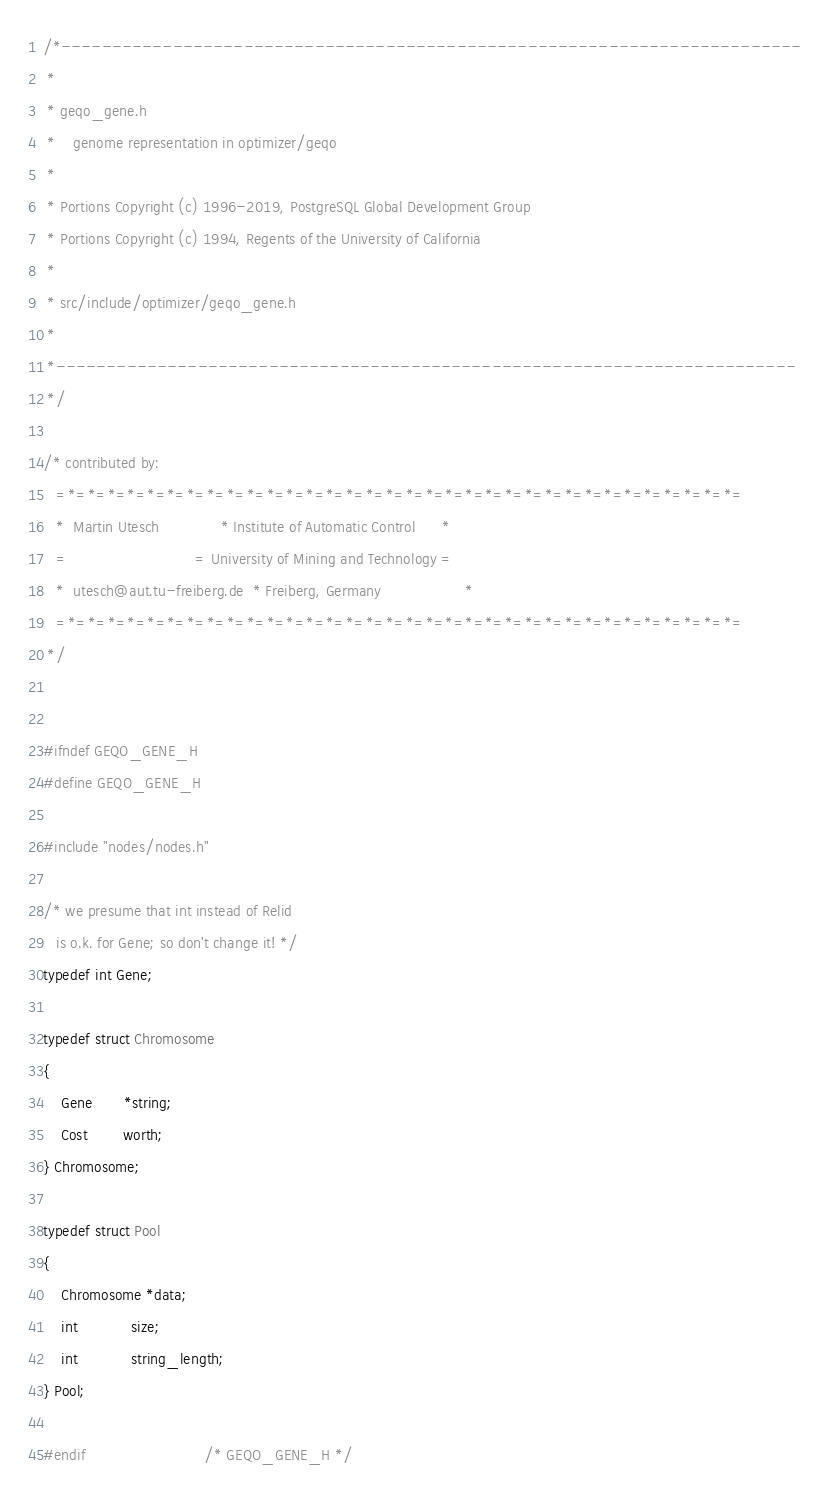Convert code to text. <code><loc_0><loc_0><loc_500><loc_500><_C_>/*-------------------------------------------------------------------------
 *
 * geqo_gene.h
 *	  genome representation in optimizer/geqo
 *
 * Portions Copyright (c) 1996-2019, PostgreSQL Global Development Group
 * Portions Copyright (c) 1994, Regents of the University of California
 *
 * src/include/optimizer/geqo_gene.h
 *
 *-------------------------------------------------------------------------
 */

/* contributed by:
   =*=*=*=*=*=*=*=*=*=*=*=*=*=*=*=*=*=*=*=*=*=*=*=*=*=*=*=*=*=*=*=*=*=*=
   *  Martin Utesch				 * Institute of Automatic Control	   *
   =							 = University of Mining and Technology =
   *  utesch@aut.tu-freiberg.de  * Freiberg, Germany				   *
   =*=*=*=*=*=*=*=*=*=*=*=*=*=*=*=*=*=*=*=*=*=*=*=*=*=*=*=*=*=*=*=*=*=*=
 */


#ifndef GEQO_GENE_H
#define GEQO_GENE_H

#include "nodes/nodes.h"

/* we presume that int instead of Relid
   is o.k. for Gene; so don't change it! */
typedef int Gene;

typedef struct Chromosome
{
	Gene	   *string;
	Cost		worth;
} Chromosome;

typedef struct Pool
{
	Chromosome *data;
	int			size;
	int			string_length;
} Pool;

#endif							/* GEQO_GENE_H */
</code> 